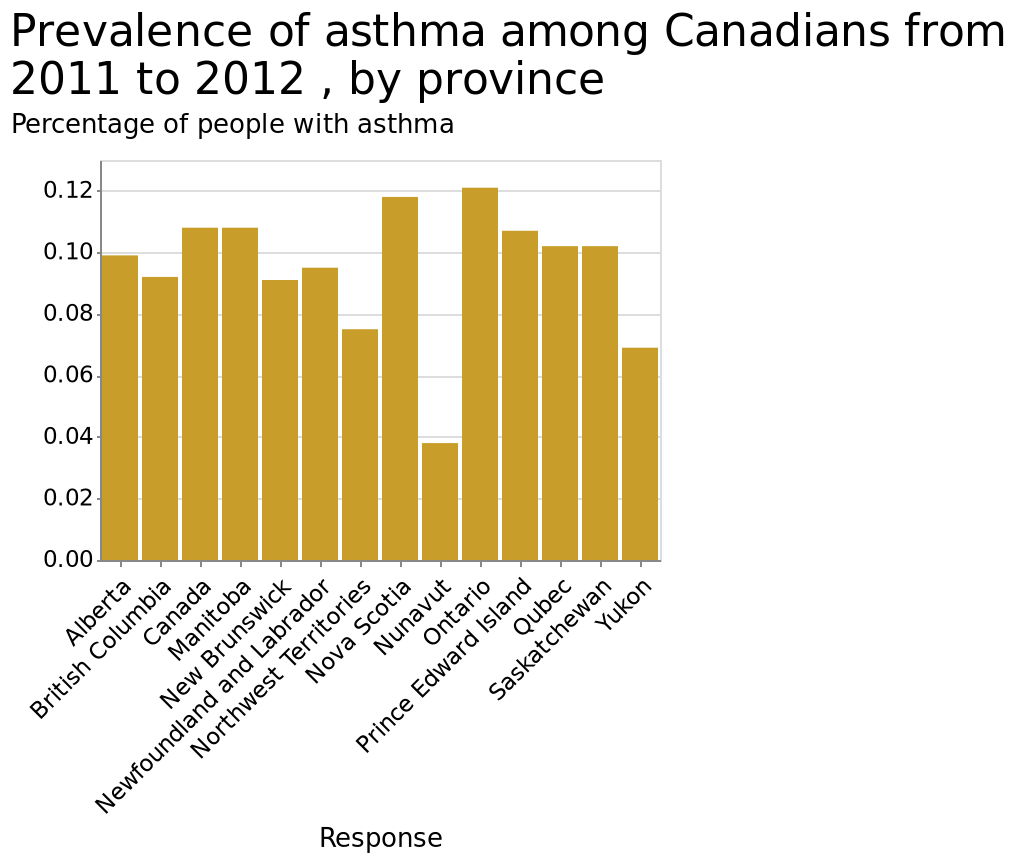<image>
What does the x-axis represent in the bar chart? The x-axis represents the provinces in Canada, starting from Alberta and ending at Yukon. please describe the details of the chart This is a bar chart titled Prevalence of asthma among Canadians from 2011 to 2012 , by province. The y-axis shows Percentage of people with asthma with linear scale from 0.00 to 0.12 while the x-axis shows Response as categorical scale starting at Alberta and ending at Yukon. Which provinces in Canada have the largest number of asthma cases?  The largest number of asthma cases are recorded in Nova Scotia and Ontario, both coming in at around 0.12 per 100,000. What is the prevalence of asthma in Nunavut compared to the rest of Canada?  The prevalence of asthma in Nunavut is roughly half of the cases in the rest of the country (0.04 per 100,000). Are there any provinces in Canada with significantly lower rates of asthma compared to the rest? Yes, Nunavut has significantly lower rates of asthma compared to the rest of Canada. It has roughly half the number of cases (0.04 per 100,000). What is the title of the bar chart?  The title of the bar chart is "Prevalence of asthma among Canadians from 2011 to 2012, by province." 